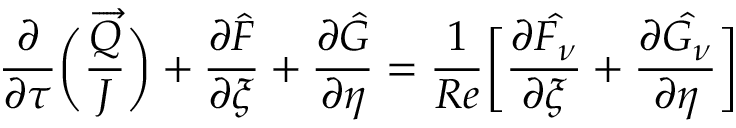<formula> <loc_0><loc_0><loc_500><loc_500>\frac { \partial } { \partial \tau } \left ( \frac { \overrightarrow { Q } } { J } \right ) + \frac { \partial \hat { F } } { \partial \xi } + \frac { \partial \hat { G } } { \partial \eta } = \frac { 1 } { R e } \left [ \frac { \partial \hat { F _ { \nu } } } { \partial \xi } + \frac { \partial \hat { G _ { \nu } } } { \partial \eta } \right ]</formula> 